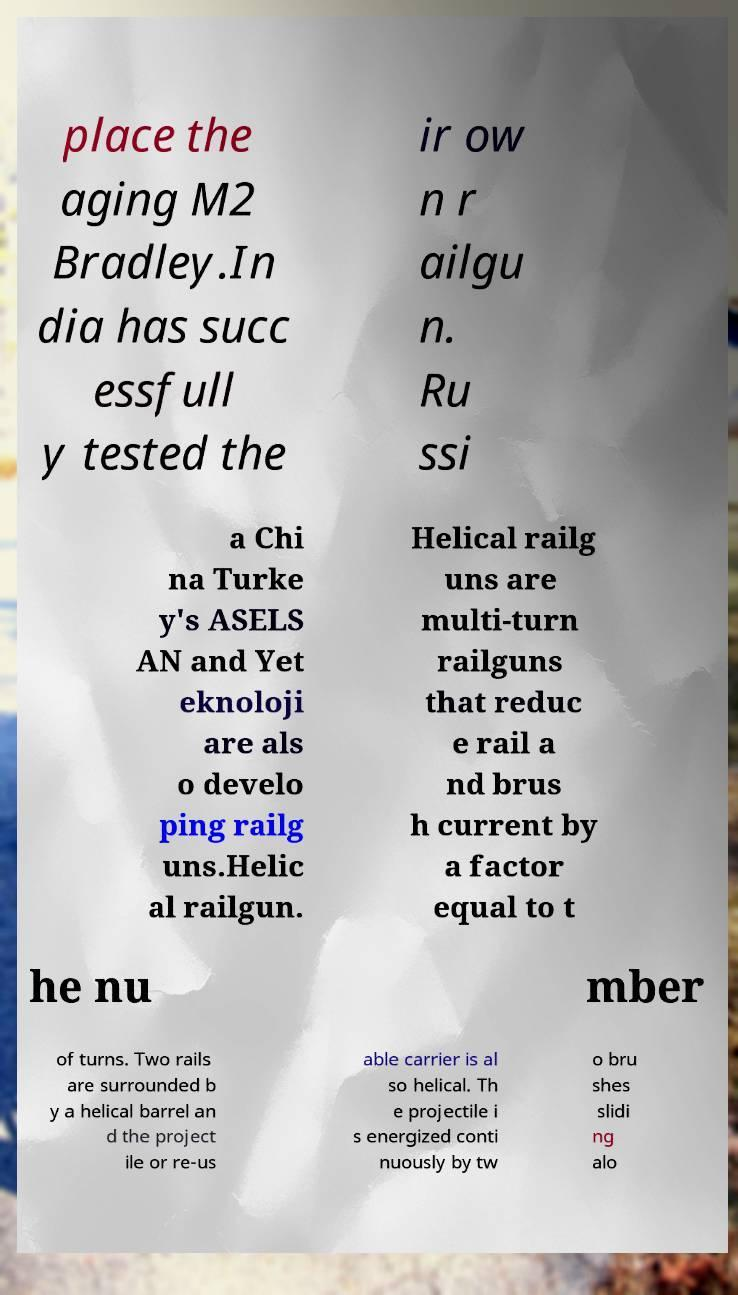I need the written content from this picture converted into text. Can you do that? place the aging M2 Bradley.In dia has succ essfull y tested the ir ow n r ailgu n. Ru ssi a Chi na Turke y's ASELS AN and Yet eknoloji are als o develo ping railg uns.Helic al railgun. Helical railg uns are multi-turn railguns that reduc e rail a nd brus h current by a factor equal to t he nu mber of turns. Two rails are surrounded b y a helical barrel an d the project ile or re-us able carrier is al so helical. Th e projectile i s energized conti nuously by tw o bru shes slidi ng alo 